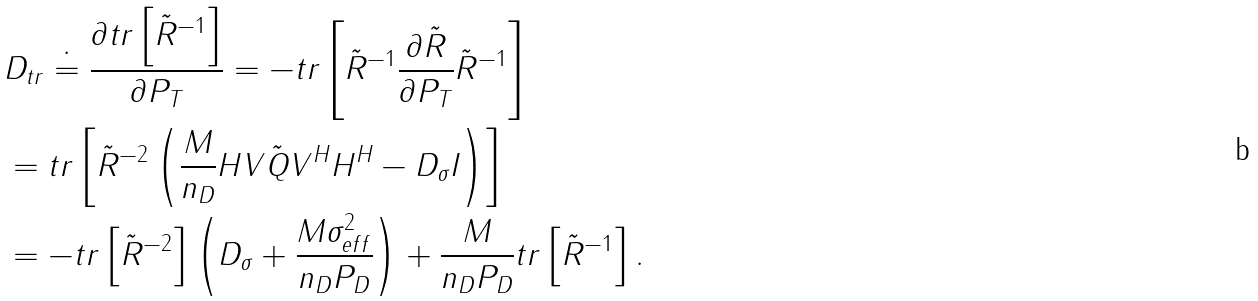Convert formula to latex. <formula><loc_0><loc_0><loc_500><loc_500>& D _ { t r } \doteq \frac { \partial t r \left [ \tilde { R } ^ { - 1 } \right ] } { \partial P _ { T } } = - t r \left [ \tilde { R } ^ { - 1 } \frac { \partial \tilde { R } } { \partial P _ { T } } \tilde { R } ^ { - 1 } \right ] \\ & = t r \left [ \tilde { R } ^ { - 2 } \left ( \frac { M } { n _ { D } } H V \tilde { Q } V ^ { H } H ^ { H } - D _ { \sigma } I \right ) \right ] \\ & = - t r \left [ \tilde { R } ^ { - 2 } \right ] \left ( D _ { \sigma } + \frac { M \sigma _ { e f f } ^ { 2 } } { n _ { D } P _ { D } } \right ) + \frac { M } { n _ { D } P _ { D } } t r \left [ \tilde { R } ^ { - 1 } \right ] .</formula> 